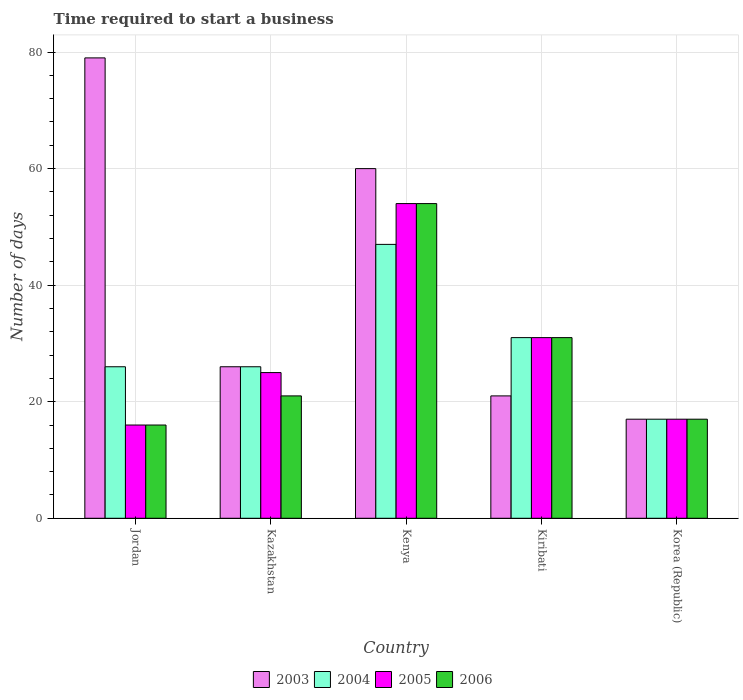How many bars are there on the 3rd tick from the left?
Provide a short and direct response. 4. What is the label of the 4th group of bars from the left?
Your answer should be compact. Kiribati. In how many cases, is the number of bars for a given country not equal to the number of legend labels?
Offer a terse response. 0. In which country was the number of days required to start a business in 2004 maximum?
Make the answer very short. Kenya. In which country was the number of days required to start a business in 2006 minimum?
Your answer should be compact. Jordan. What is the total number of days required to start a business in 2006 in the graph?
Offer a terse response. 139. What is the average number of days required to start a business in 2006 per country?
Your response must be concise. 27.8. What is the difference between the number of days required to start a business of/in 2004 and number of days required to start a business of/in 2003 in Jordan?
Provide a short and direct response. -53. In how many countries, is the number of days required to start a business in 2006 greater than 48 days?
Ensure brevity in your answer.  1. What is the ratio of the number of days required to start a business in 2005 in Jordan to that in Kiribati?
Your answer should be compact. 0.52. Is the difference between the number of days required to start a business in 2004 in Jordan and Kazakhstan greater than the difference between the number of days required to start a business in 2003 in Jordan and Kazakhstan?
Provide a short and direct response. No. What does the 4th bar from the left in Korea (Republic) represents?
Ensure brevity in your answer.  2006. What does the 4th bar from the right in Kenya represents?
Offer a very short reply. 2003. How many bars are there?
Provide a succinct answer. 20. Are all the bars in the graph horizontal?
Offer a very short reply. No. How many countries are there in the graph?
Ensure brevity in your answer.  5. What is the difference between two consecutive major ticks on the Y-axis?
Offer a very short reply. 20. Are the values on the major ticks of Y-axis written in scientific E-notation?
Make the answer very short. No. Does the graph contain any zero values?
Ensure brevity in your answer.  No. How many legend labels are there?
Your answer should be very brief. 4. How are the legend labels stacked?
Provide a short and direct response. Horizontal. What is the title of the graph?
Offer a very short reply. Time required to start a business. Does "1998" appear as one of the legend labels in the graph?
Offer a terse response. No. What is the label or title of the Y-axis?
Keep it short and to the point. Number of days. What is the Number of days in 2003 in Jordan?
Provide a succinct answer. 79. What is the Number of days of 2004 in Jordan?
Provide a short and direct response. 26. What is the Number of days of 2006 in Jordan?
Offer a terse response. 16. What is the Number of days of 2004 in Kazakhstan?
Make the answer very short. 26. What is the Number of days of 2005 in Kazakhstan?
Give a very brief answer. 25. What is the Number of days in 2004 in Kenya?
Your answer should be very brief. 47. What is the Number of days in 2003 in Kiribati?
Provide a succinct answer. 21. What is the Number of days of 2006 in Kiribati?
Offer a very short reply. 31. What is the Number of days in 2003 in Korea (Republic)?
Give a very brief answer. 17. What is the Number of days in 2004 in Korea (Republic)?
Your answer should be very brief. 17. What is the Number of days of 2005 in Korea (Republic)?
Make the answer very short. 17. What is the Number of days of 2006 in Korea (Republic)?
Your answer should be compact. 17. Across all countries, what is the maximum Number of days in 2003?
Provide a short and direct response. 79. Across all countries, what is the maximum Number of days of 2004?
Ensure brevity in your answer.  47. Across all countries, what is the maximum Number of days of 2005?
Make the answer very short. 54. Across all countries, what is the maximum Number of days of 2006?
Offer a terse response. 54. What is the total Number of days of 2003 in the graph?
Keep it short and to the point. 203. What is the total Number of days in 2004 in the graph?
Offer a very short reply. 147. What is the total Number of days in 2005 in the graph?
Your response must be concise. 143. What is the total Number of days in 2006 in the graph?
Offer a very short reply. 139. What is the difference between the Number of days of 2005 in Jordan and that in Kazakhstan?
Give a very brief answer. -9. What is the difference between the Number of days in 2006 in Jordan and that in Kazakhstan?
Your answer should be very brief. -5. What is the difference between the Number of days of 2003 in Jordan and that in Kenya?
Your response must be concise. 19. What is the difference between the Number of days of 2005 in Jordan and that in Kenya?
Offer a very short reply. -38. What is the difference between the Number of days in 2006 in Jordan and that in Kenya?
Your response must be concise. -38. What is the difference between the Number of days of 2004 in Jordan and that in Kiribati?
Provide a short and direct response. -5. What is the difference between the Number of days in 2005 in Jordan and that in Kiribati?
Your answer should be compact. -15. What is the difference between the Number of days in 2006 in Jordan and that in Kiribati?
Ensure brevity in your answer.  -15. What is the difference between the Number of days in 2003 in Jordan and that in Korea (Republic)?
Make the answer very short. 62. What is the difference between the Number of days in 2004 in Jordan and that in Korea (Republic)?
Give a very brief answer. 9. What is the difference between the Number of days in 2005 in Jordan and that in Korea (Republic)?
Your answer should be very brief. -1. What is the difference between the Number of days in 2006 in Jordan and that in Korea (Republic)?
Your answer should be very brief. -1. What is the difference between the Number of days in 2003 in Kazakhstan and that in Kenya?
Keep it short and to the point. -34. What is the difference between the Number of days of 2006 in Kazakhstan and that in Kenya?
Provide a succinct answer. -33. What is the difference between the Number of days of 2004 in Kazakhstan and that in Kiribati?
Give a very brief answer. -5. What is the difference between the Number of days in 2005 in Kazakhstan and that in Kiribati?
Your answer should be compact. -6. What is the difference between the Number of days in 2006 in Kazakhstan and that in Kiribati?
Offer a very short reply. -10. What is the difference between the Number of days of 2003 in Kazakhstan and that in Korea (Republic)?
Offer a very short reply. 9. What is the difference between the Number of days in 2006 in Kazakhstan and that in Korea (Republic)?
Provide a short and direct response. 4. What is the difference between the Number of days in 2004 in Kenya and that in Kiribati?
Your response must be concise. 16. What is the difference between the Number of days in 2005 in Kenya and that in Kiribati?
Your answer should be very brief. 23. What is the difference between the Number of days in 2006 in Kenya and that in Kiribati?
Keep it short and to the point. 23. What is the difference between the Number of days in 2003 in Kenya and that in Korea (Republic)?
Your answer should be compact. 43. What is the difference between the Number of days in 2003 in Kiribati and that in Korea (Republic)?
Ensure brevity in your answer.  4. What is the difference between the Number of days in 2004 in Jordan and the Number of days in 2005 in Kazakhstan?
Offer a terse response. 1. What is the difference between the Number of days in 2004 in Jordan and the Number of days in 2006 in Kazakhstan?
Provide a short and direct response. 5. What is the difference between the Number of days in 2003 in Jordan and the Number of days in 2004 in Kenya?
Make the answer very short. 32. What is the difference between the Number of days in 2003 in Jordan and the Number of days in 2005 in Kenya?
Ensure brevity in your answer.  25. What is the difference between the Number of days in 2003 in Jordan and the Number of days in 2006 in Kenya?
Provide a short and direct response. 25. What is the difference between the Number of days in 2004 in Jordan and the Number of days in 2005 in Kenya?
Ensure brevity in your answer.  -28. What is the difference between the Number of days in 2004 in Jordan and the Number of days in 2006 in Kenya?
Provide a short and direct response. -28. What is the difference between the Number of days of 2005 in Jordan and the Number of days of 2006 in Kenya?
Give a very brief answer. -38. What is the difference between the Number of days in 2003 in Jordan and the Number of days in 2004 in Kiribati?
Provide a succinct answer. 48. What is the difference between the Number of days in 2005 in Jordan and the Number of days in 2006 in Kiribati?
Make the answer very short. -15. What is the difference between the Number of days in 2003 in Jordan and the Number of days in 2004 in Korea (Republic)?
Offer a very short reply. 62. What is the difference between the Number of days in 2003 in Jordan and the Number of days in 2006 in Korea (Republic)?
Give a very brief answer. 62. What is the difference between the Number of days of 2004 in Jordan and the Number of days of 2006 in Korea (Republic)?
Make the answer very short. 9. What is the difference between the Number of days of 2005 in Jordan and the Number of days of 2006 in Korea (Republic)?
Ensure brevity in your answer.  -1. What is the difference between the Number of days in 2003 in Kazakhstan and the Number of days in 2004 in Kenya?
Provide a succinct answer. -21. What is the difference between the Number of days of 2003 in Kazakhstan and the Number of days of 2006 in Kenya?
Make the answer very short. -28. What is the difference between the Number of days in 2004 in Kazakhstan and the Number of days in 2006 in Kenya?
Your response must be concise. -28. What is the difference between the Number of days in 2005 in Kazakhstan and the Number of days in 2006 in Kenya?
Make the answer very short. -29. What is the difference between the Number of days in 2003 in Kazakhstan and the Number of days in 2005 in Kiribati?
Provide a succinct answer. -5. What is the difference between the Number of days of 2003 in Kazakhstan and the Number of days of 2006 in Kiribati?
Your response must be concise. -5. What is the difference between the Number of days in 2005 in Kazakhstan and the Number of days in 2006 in Kiribati?
Provide a short and direct response. -6. What is the difference between the Number of days in 2003 in Kazakhstan and the Number of days in 2005 in Korea (Republic)?
Your answer should be very brief. 9. What is the difference between the Number of days of 2003 in Kazakhstan and the Number of days of 2006 in Korea (Republic)?
Give a very brief answer. 9. What is the difference between the Number of days in 2005 in Kazakhstan and the Number of days in 2006 in Korea (Republic)?
Offer a terse response. 8. What is the difference between the Number of days of 2004 in Kenya and the Number of days of 2006 in Kiribati?
Offer a terse response. 16. What is the difference between the Number of days in 2003 in Kiribati and the Number of days in 2005 in Korea (Republic)?
Your answer should be compact. 4. What is the difference between the Number of days in 2003 in Kiribati and the Number of days in 2006 in Korea (Republic)?
Offer a very short reply. 4. What is the average Number of days of 2003 per country?
Offer a very short reply. 40.6. What is the average Number of days of 2004 per country?
Give a very brief answer. 29.4. What is the average Number of days in 2005 per country?
Give a very brief answer. 28.6. What is the average Number of days in 2006 per country?
Provide a succinct answer. 27.8. What is the difference between the Number of days of 2003 and Number of days of 2005 in Jordan?
Give a very brief answer. 63. What is the difference between the Number of days in 2003 and Number of days in 2006 in Jordan?
Ensure brevity in your answer.  63. What is the difference between the Number of days of 2004 and Number of days of 2005 in Jordan?
Your answer should be very brief. 10. What is the difference between the Number of days in 2004 and Number of days in 2006 in Jordan?
Ensure brevity in your answer.  10. What is the difference between the Number of days in 2003 and Number of days in 2005 in Kazakhstan?
Make the answer very short. 1. What is the difference between the Number of days of 2003 and Number of days of 2006 in Kazakhstan?
Your response must be concise. 5. What is the difference between the Number of days in 2004 and Number of days in 2005 in Kazakhstan?
Make the answer very short. 1. What is the difference between the Number of days in 2004 and Number of days in 2006 in Kazakhstan?
Provide a short and direct response. 5. What is the difference between the Number of days of 2005 and Number of days of 2006 in Kazakhstan?
Offer a very short reply. 4. What is the difference between the Number of days of 2003 and Number of days of 2004 in Kenya?
Provide a succinct answer. 13. What is the difference between the Number of days in 2003 and Number of days in 2005 in Kenya?
Offer a terse response. 6. What is the difference between the Number of days of 2003 and Number of days of 2006 in Kenya?
Offer a terse response. 6. What is the difference between the Number of days of 2004 and Number of days of 2005 in Kenya?
Make the answer very short. -7. What is the difference between the Number of days in 2004 and Number of days in 2006 in Kiribati?
Make the answer very short. 0. What is the difference between the Number of days of 2003 and Number of days of 2004 in Korea (Republic)?
Give a very brief answer. 0. What is the difference between the Number of days of 2003 and Number of days of 2006 in Korea (Republic)?
Provide a short and direct response. 0. What is the difference between the Number of days of 2004 and Number of days of 2005 in Korea (Republic)?
Give a very brief answer. 0. What is the difference between the Number of days of 2004 and Number of days of 2006 in Korea (Republic)?
Keep it short and to the point. 0. What is the ratio of the Number of days of 2003 in Jordan to that in Kazakhstan?
Your answer should be compact. 3.04. What is the ratio of the Number of days of 2004 in Jordan to that in Kazakhstan?
Offer a very short reply. 1. What is the ratio of the Number of days in 2005 in Jordan to that in Kazakhstan?
Keep it short and to the point. 0.64. What is the ratio of the Number of days of 2006 in Jordan to that in Kazakhstan?
Ensure brevity in your answer.  0.76. What is the ratio of the Number of days in 2003 in Jordan to that in Kenya?
Make the answer very short. 1.32. What is the ratio of the Number of days of 2004 in Jordan to that in Kenya?
Your response must be concise. 0.55. What is the ratio of the Number of days in 2005 in Jordan to that in Kenya?
Your response must be concise. 0.3. What is the ratio of the Number of days of 2006 in Jordan to that in Kenya?
Your answer should be very brief. 0.3. What is the ratio of the Number of days in 2003 in Jordan to that in Kiribati?
Ensure brevity in your answer.  3.76. What is the ratio of the Number of days of 2004 in Jordan to that in Kiribati?
Offer a very short reply. 0.84. What is the ratio of the Number of days in 2005 in Jordan to that in Kiribati?
Offer a very short reply. 0.52. What is the ratio of the Number of days of 2006 in Jordan to that in Kiribati?
Offer a very short reply. 0.52. What is the ratio of the Number of days of 2003 in Jordan to that in Korea (Republic)?
Your answer should be compact. 4.65. What is the ratio of the Number of days of 2004 in Jordan to that in Korea (Republic)?
Keep it short and to the point. 1.53. What is the ratio of the Number of days of 2005 in Jordan to that in Korea (Republic)?
Offer a very short reply. 0.94. What is the ratio of the Number of days of 2006 in Jordan to that in Korea (Republic)?
Ensure brevity in your answer.  0.94. What is the ratio of the Number of days of 2003 in Kazakhstan to that in Kenya?
Your answer should be very brief. 0.43. What is the ratio of the Number of days in 2004 in Kazakhstan to that in Kenya?
Give a very brief answer. 0.55. What is the ratio of the Number of days in 2005 in Kazakhstan to that in Kenya?
Provide a succinct answer. 0.46. What is the ratio of the Number of days in 2006 in Kazakhstan to that in Kenya?
Provide a succinct answer. 0.39. What is the ratio of the Number of days of 2003 in Kazakhstan to that in Kiribati?
Ensure brevity in your answer.  1.24. What is the ratio of the Number of days in 2004 in Kazakhstan to that in Kiribati?
Keep it short and to the point. 0.84. What is the ratio of the Number of days of 2005 in Kazakhstan to that in Kiribati?
Ensure brevity in your answer.  0.81. What is the ratio of the Number of days of 2006 in Kazakhstan to that in Kiribati?
Offer a very short reply. 0.68. What is the ratio of the Number of days in 2003 in Kazakhstan to that in Korea (Republic)?
Ensure brevity in your answer.  1.53. What is the ratio of the Number of days of 2004 in Kazakhstan to that in Korea (Republic)?
Offer a very short reply. 1.53. What is the ratio of the Number of days of 2005 in Kazakhstan to that in Korea (Republic)?
Provide a short and direct response. 1.47. What is the ratio of the Number of days in 2006 in Kazakhstan to that in Korea (Republic)?
Provide a succinct answer. 1.24. What is the ratio of the Number of days in 2003 in Kenya to that in Kiribati?
Provide a succinct answer. 2.86. What is the ratio of the Number of days in 2004 in Kenya to that in Kiribati?
Make the answer very short. 1.52. What is the ratio of the Number of days in 2005 in Kenya to that in Kiribati?
Provide a short and direct response. 1.74. What is the ratio of the Number of days in 2006 in Kenya to that in Kiribati?
Keep it short and to the point. 1.74. What is the ratio of the Number of days in 2003 in Kenya to that in Korea (Republic)?
Provide a short and direct response. 3.53. What is the ratio of the Number of days in 2004 in Kenya to that in Korea (Republic)?
Your response must be concise. 2.76. What is the ratio of the Number of days of 2005 in Kenya to that in Korea (Republic)?
Keep it short and to the point. 3.18. What is the ratio of the Number of days in 2006 in Kenya to that in Korea (Republic)?
Provide a succinct answer. 3.18. What is the ratio of the Number of days of 2003 in Kiribati to that in Korea (Republic)?
Your answer should be compact. 1.24. What is the ratio of the Number of days in 2004 in Kiribati to that in Korea (Republic)?
Keep it short and to the point. 1.82. What is the ratio of the Number of days of 2005 in Kiribati to that in Korea (Republic)?
Provide a short and direct response. 1.82. What is the ratio of the Number of days in 2006 in Kiribati to that in Korea (Republic)?
Keep it short and to the point. 1.82. What is the difference between the highest and the second highest Number of days in 2003?
Give a very brief answer. 19. What is the difference between the highest and the second highest Number of days in 2005?
Provide a succinct answer. 23. What is the difference between the highest and the lowest Number of days of 2003?
Give a very brief answer. 62. What is the difference between the highest and the lowest Number of days in 2006?
Make the answer very short. 38. 